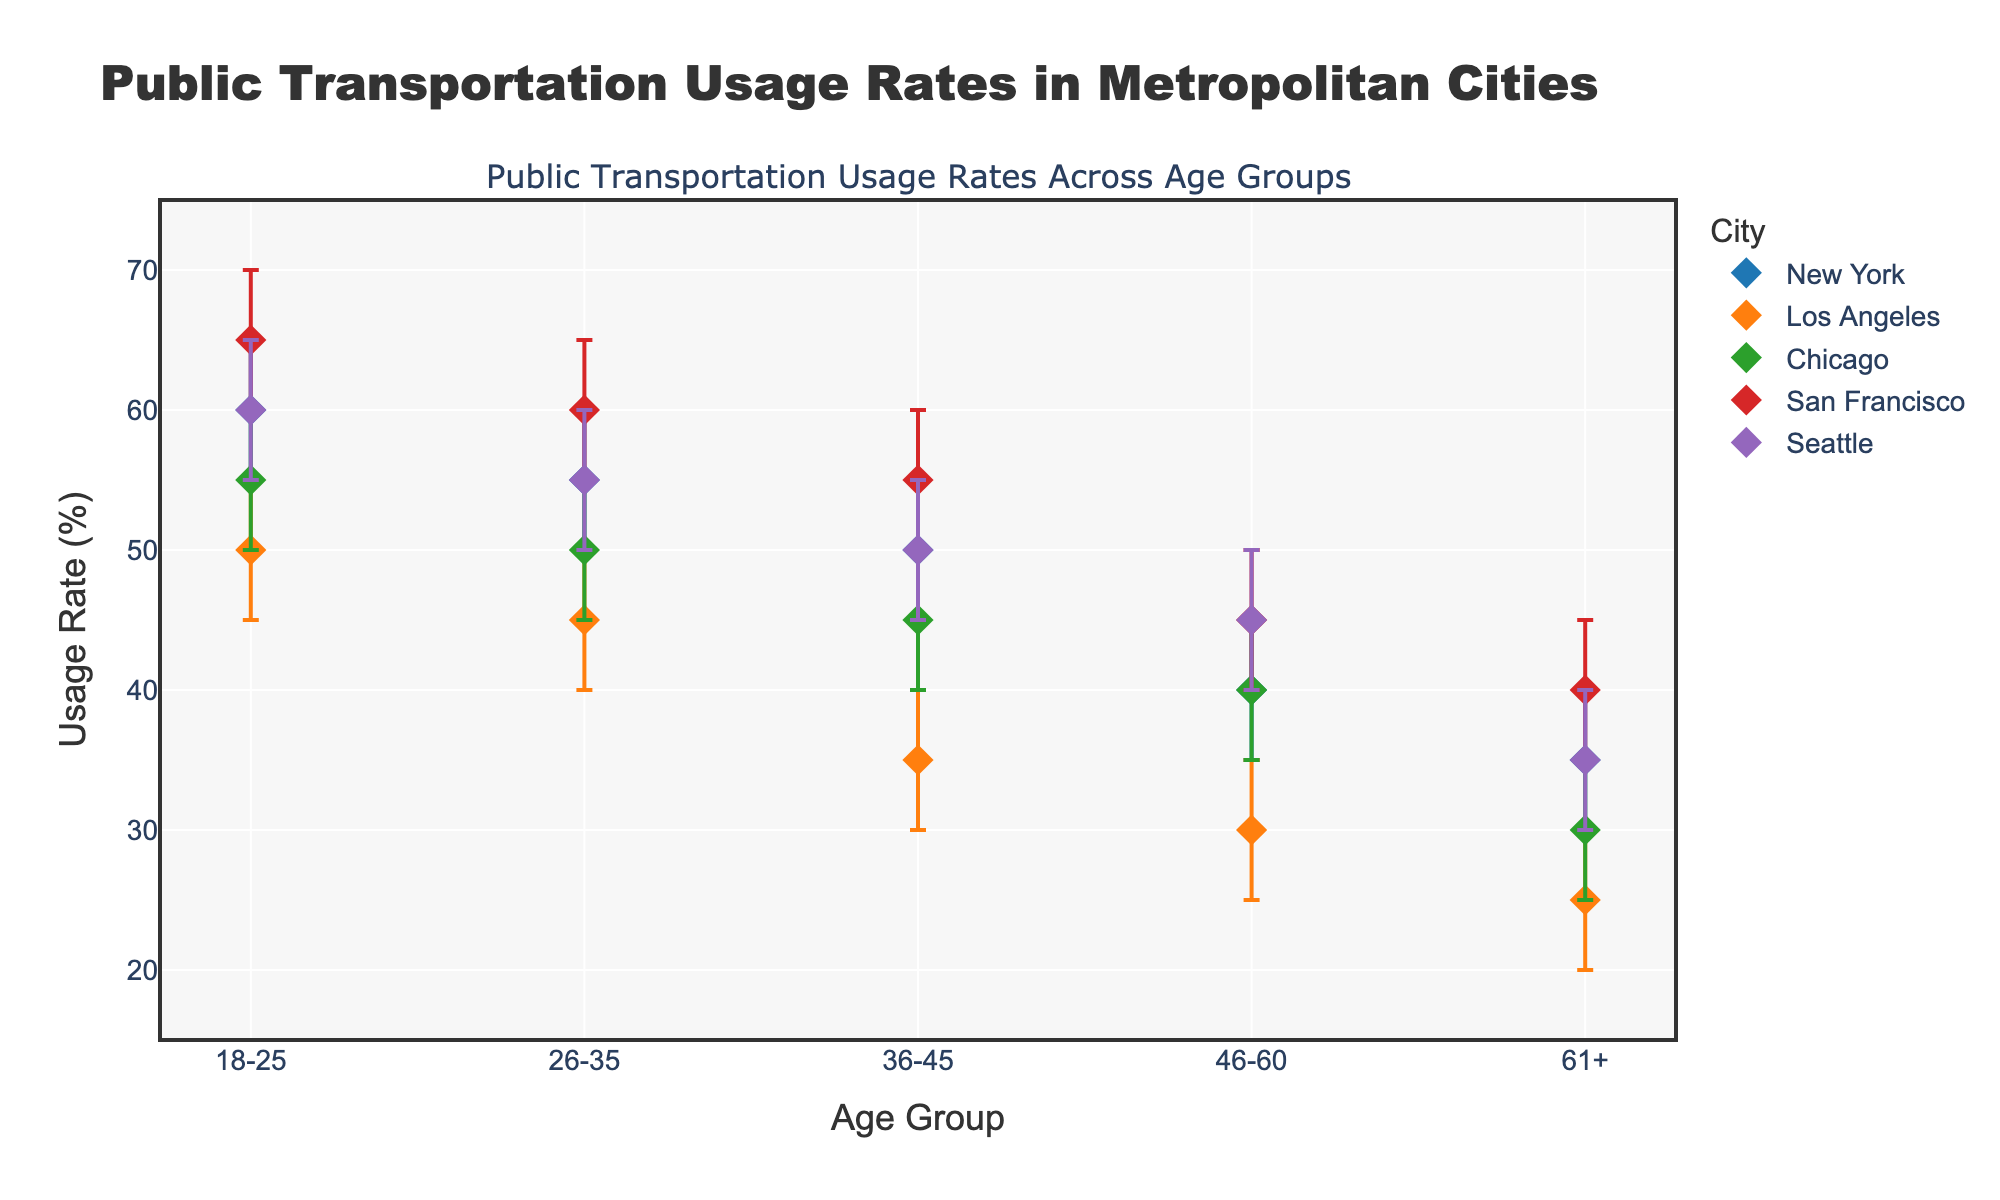What's the title of the figure? The title is located at the top of the figure, it reads "Public Transportation Usage Rates in Metropolitan Cities".
Answer: Public Transportation Usage Rates in Metropolitan Cities What is the overall trend in usage rate across age groups in New York? By observing the markers for New York, it can be seen that the usage rate decreases as age increases, starting from 60% in the 18-25 group to 35% in the 61+ group.
Answer: Decreases with age Which city has the highest usage rate for the 18-25 age group? By comparing the data points for the 18-25 age group in each city, San Francisco has the highest usage rate at 65%.
Answer: San Francisco How does the usage rate for the 26-35 age group compare between Chicago and Seattle? The usage rates for the 26-35 age group are 50% in Chicago and 55% in Seattle. Seattle has a higher usage rate.
Answer: Seattle has a higher usage rate What's the average usage rate for the 61+ age group across all cities? The rates for the 61+ age group in each city are 35 (New York), 25 (Los Angeles), 30 (Chicago), 40 (San Francisco), and 35 (Seattle). Sum these values (35+25+30+40+35=165) and divide by 5, the number of entries. (165/5 = 33).
Answer: 33% In which age group does San Francisco have the lowest usage rate? For San Francisco, observe the data points: lowest usage rate is 40% in the 61+ age group.
Answer: 61+ age group Which city shows the smallest error range in the 36-45 age group? The error range is calculated by subtracting the lower error from the upper error. For 36-45 age groups: New York (10), Los Angeles (10), Chicago (10), San Francisco (10), Seattle (10). Equal smallest error range observed.
Answer: All cities have equal error ranges Is there any age group in Los Angeles where the usage rate exceeds 50%? By examining the markers for Los Angeles, no age group exceeds 50% for this city. The highest rate is 50% for the 18-25 group.
Answer: No How does the usage rate for the 46-60 age group in New York compare to the same age group in San Francisco? The usage rates are 40% in New York and 45% in San Francisco. San Francisco has a higher rate.
Answer: San Francisco has a higher rate 